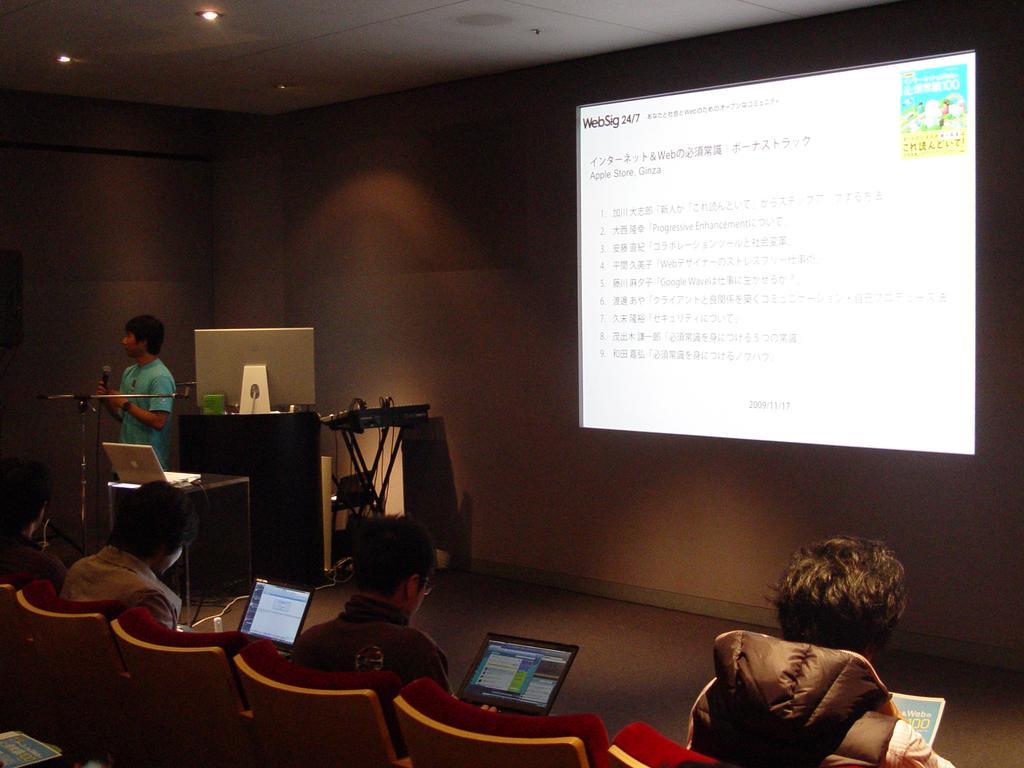Could you give a brief overview of what you see in this image? At the bottom of the image there are few people sitting on the chairs. And there are two persons holding laptops. And there is a person on the right bottom is holding a book in the hand. In the left corner of the image there is a man standing and holding a mic in the hand. Beside him there is a box with a laptop on it. Behind him there is a podium with monitor on it. And also there is a musical instrument with wires. And in the background there is a screen with some text on it. At the top of the image there is ceiling with lights. 